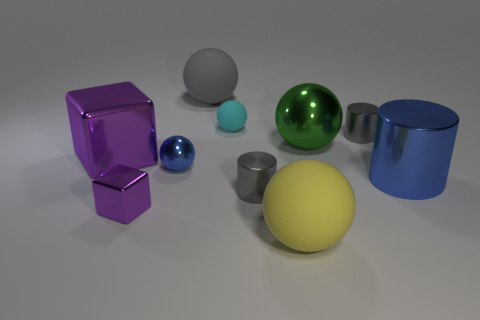Subtract all tiny cylinders. How many cylinders are left? 1 Subtract all yellow blocks. How many gray cylinders are left? 2 Subtract all green balls. How many balls are left? 4 Subtract all cylinders. How many objects are left? 7 Subtract all purple spheres. Subtract all cyan cylinders. How many spheres are left? 5 Subtract all tiny metal cylinders. Subtract all small metal cylinders. How many objects are left? 6 Add 6 tiny cyan spheres. How many tiny cyan spheres are left? 7 Add 1 metal balls. How many metal balls exist? 3 Subtract 1 purple cubes. How many objects are left? 9 